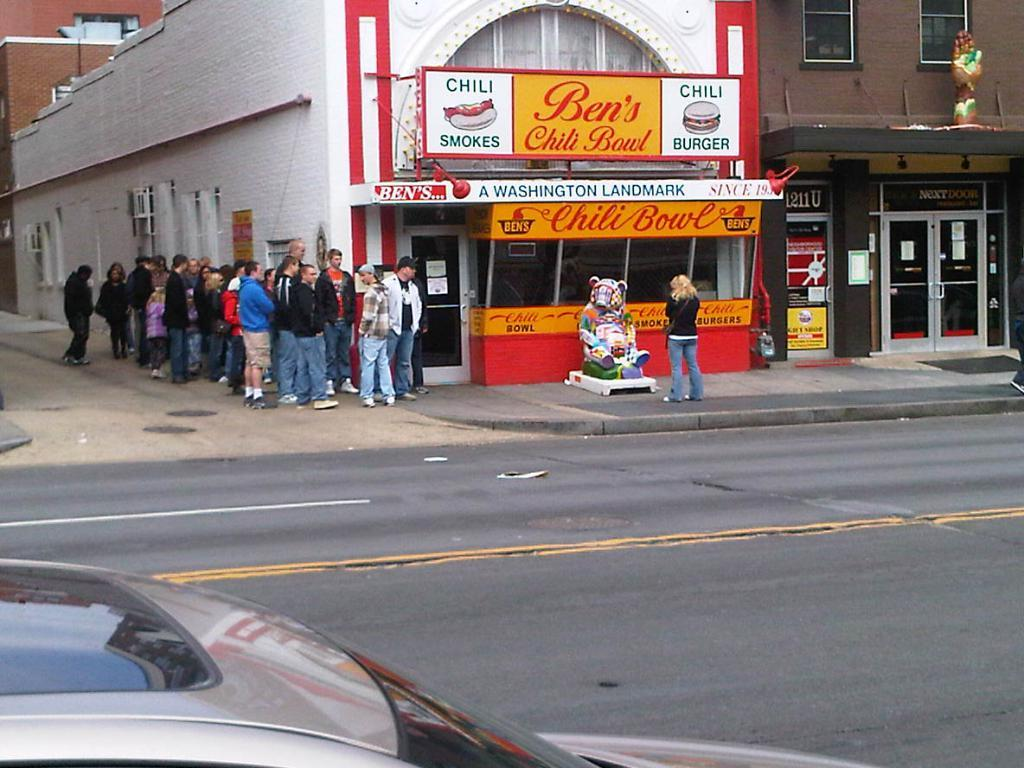<image>
Relay a brief, clear account of the picture shown. a sign that says Ben's Chili Bowl on it with people waiting 